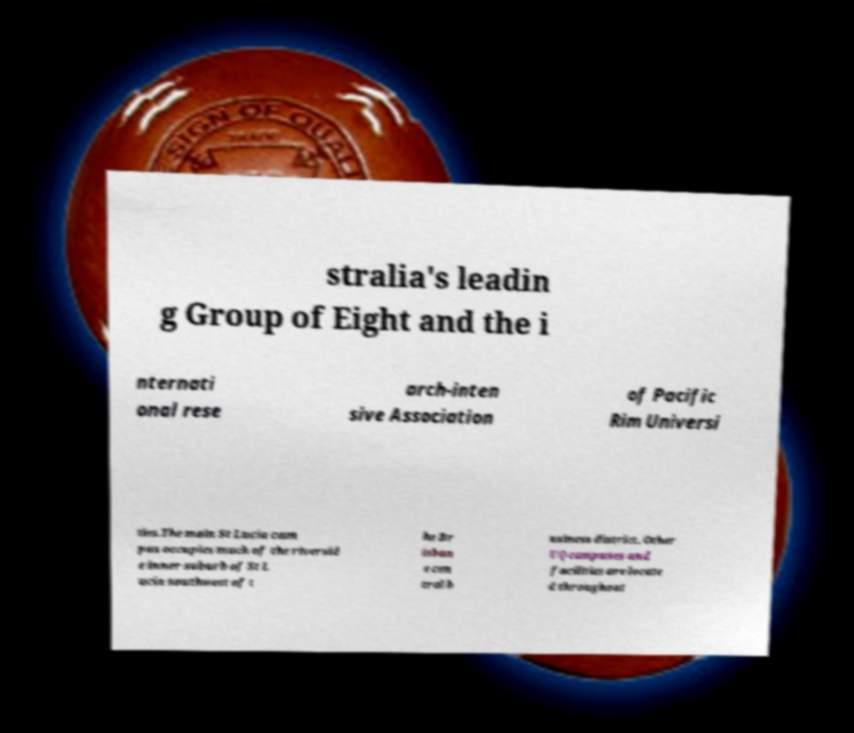Please read and relay the text visible in this image. What does it say? stralia's leadin g Group of Eight and the i nternati onal rese arch-inten sive Association of Pacific Rim Universi ties.The main St Lucia cam pus occupies much of the riversid e inner suburb of St L ucia southwest of t he Br isban e cen tral b usiness district. Other UQ campuses and facilities are locate d throughout 